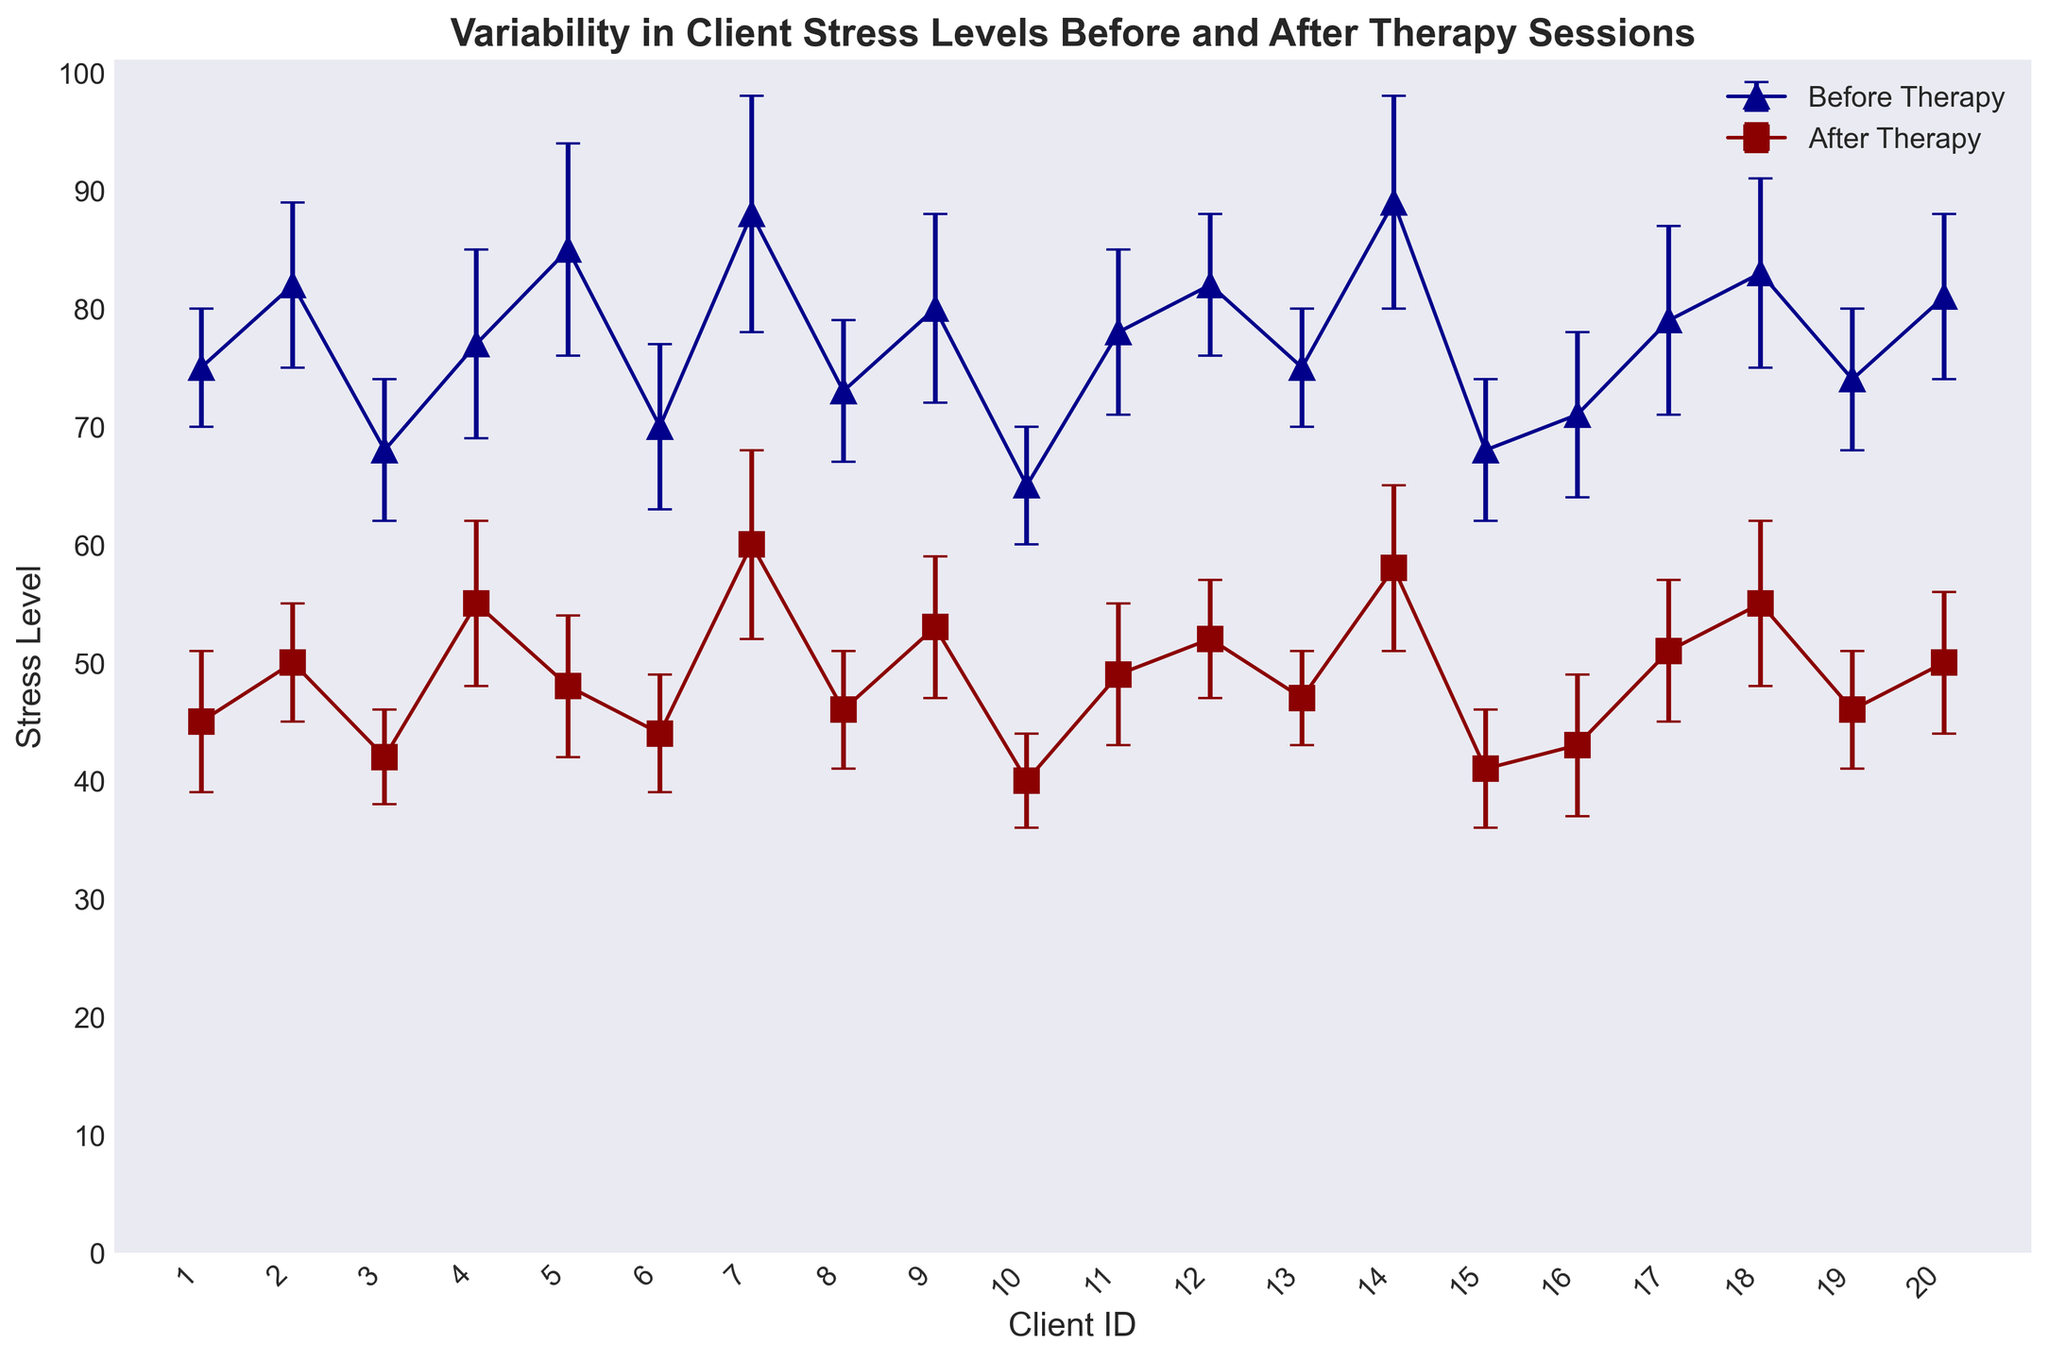Which client had the highest average stress level after therapy? By inspecting the error bars for 'After Therapy', look for the client with the highest average stress. Client 7 has the highest average stress level at 60.
Answer: Client 7 Which client experienced the largest reduction in average stress levels from before to after therapy? Calculate the reduction in average stress levels for each client. Client 7 had before therapy stress of 88 and after therapy stress of 60, which is a reduction of 28, the largest reduction.
Answer: Client 7 What was the average stress level before therapy across all clients? Sum all the average stress levels before therapy and divide by the total number of clients. (75 + 82 + 68 + 77 + 85 + 70 + 88 + 73 + 80 + 65 + 78 + 82 + 75 + 89 + 68 + 71 + 79 + 83 + 74 + 81) / 20 = 77.35
Answer: 77.35 What was the standard deviation of stress levels for Client 5 before and after therapy? Read the standard deviations for Client 5 from the chart. Before therapy: 9, After therapy: 6
Answer: Before: 9, After: 6 How many clients had a higher stress level after therapy compared to before therapy? Compare the 'Before Therapy' and 'After Therapy' values for each client, count the instances where 'After Therapy' is higher. Only Client 4 shows higher stress after therapy (55 > 77).
Answer: 1 Which client had the least variability in stress level before therapy? Determine which client has the lowest standard deviation before therapy. Client 1 has a standard deviation of 5, the lowest among all clients.
Answer: Client 1 How did the average stress level change for Client 18 after therapy? Subtract the 'After Therapy' average stress level from the 'Before Therapy' average stress level for Client 18. 83 - 55 = 28
Answer: Decreased by 28 What is the difference in the average stress level of Client 14 before and after therapy? Subtract the 'After Therapy' average stress level from the 'Before Therapy' average stress level for Client 14. 89 - 58 = 31
Answer: 31 Which client improved their stress level but still had an above-average stress level after therapy? Check clients whose stress level decreased but remained above the average post-therapy stress level calculated earlier (47.85). Client 7 is one such client.
Answer: Client 7 Which client's stress level standard deviation increased after therapy? Compare the standard deviations before and after therapy for each client. Client 1 had a before therapy stddev of 5 and an after therapy stddev of 6, indicating an increase.
Answer: Client 1 